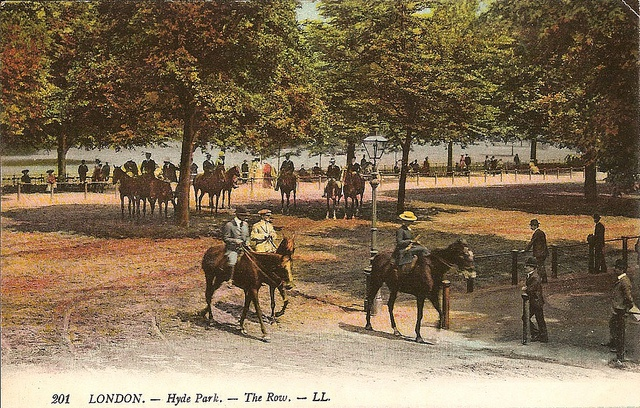Describe the objects in this image and their specific colors. I can see horse in black and gray tones, horse in black, maroon, and gray tones, people in black, gray, and tan tones, people in black and gray tones, and people in black and gray tones in this image. 